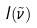<formula> <loc_0><loc_0><loc_500><loc_500>I ( \tilde { \nu } )</formula> 